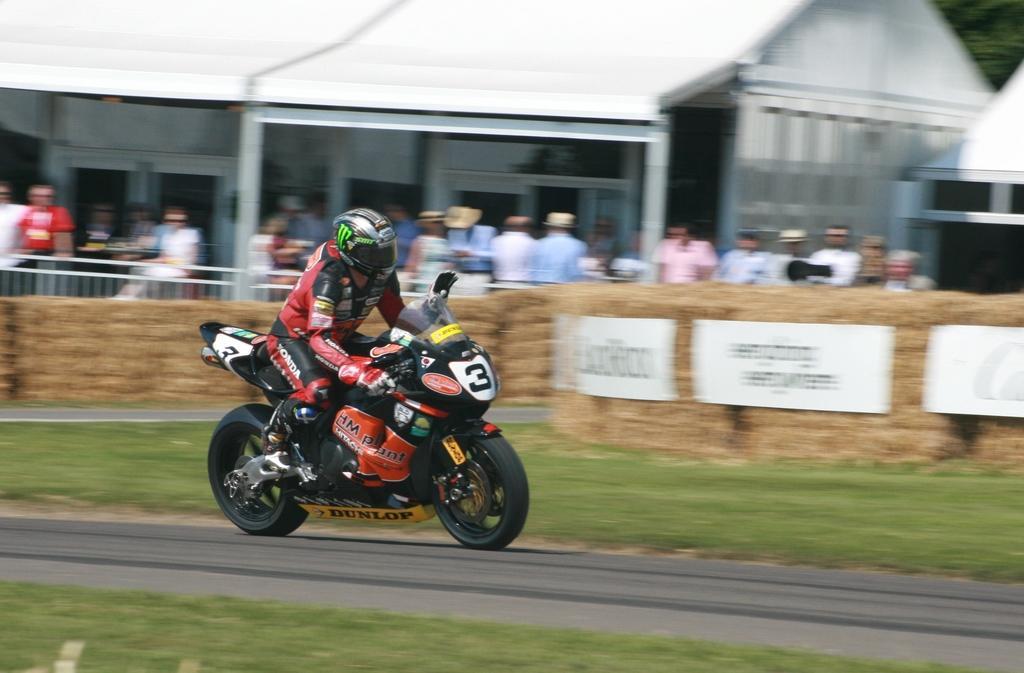Describe this image in one or two sentences. The person wearing a red jacket is riding a bike on the road and there are group of people beside him. 